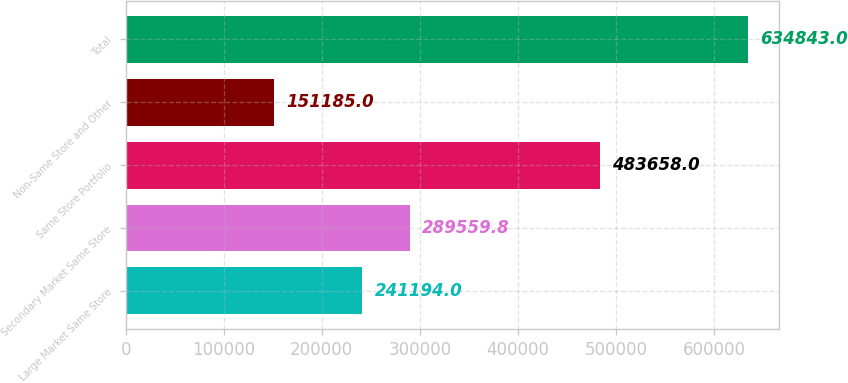Convert chart to OTSL. <chart><loc_0><loc_0><loc_500><loc_500><bar_chart><fcel>Large Market Same Store<fcel>Secondary Market Same Store<fcel>Same Store Portfolio<fcel>Non-Same Store and Other<fcel>Total<nl><fcel>241194<fcel>289560<fcel>483658<fcel>151185<fcel>634843<nl></chart> 